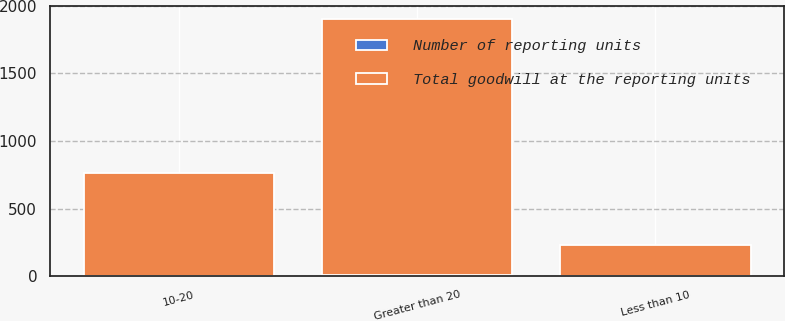<chart> <loc_0><loc_0><loc_500><loc_500><stacked_bar_chart><ecel><fcel>Less than 10<fcel>10-20<fcel>Greater than 20<nl><fcel>Number of reporting units<fcel>3<fcel>3<fcel>7<nl><fcel>Total goodwill at the reporting units<fcel>231.1<fcel>759.9<fcel>1899.1<nl></chart> 